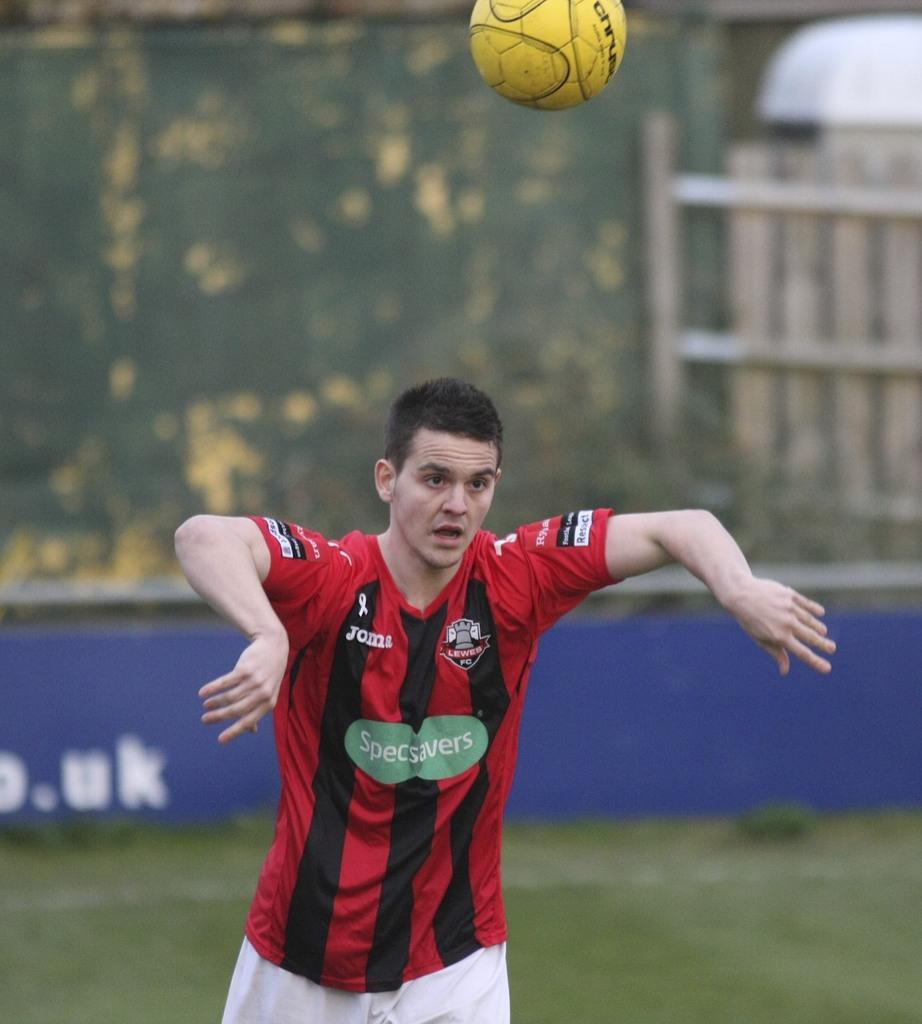<image>
Share a concise interpretation of the image provided. The soccer player has Specsavers and Joma on his shirt. 